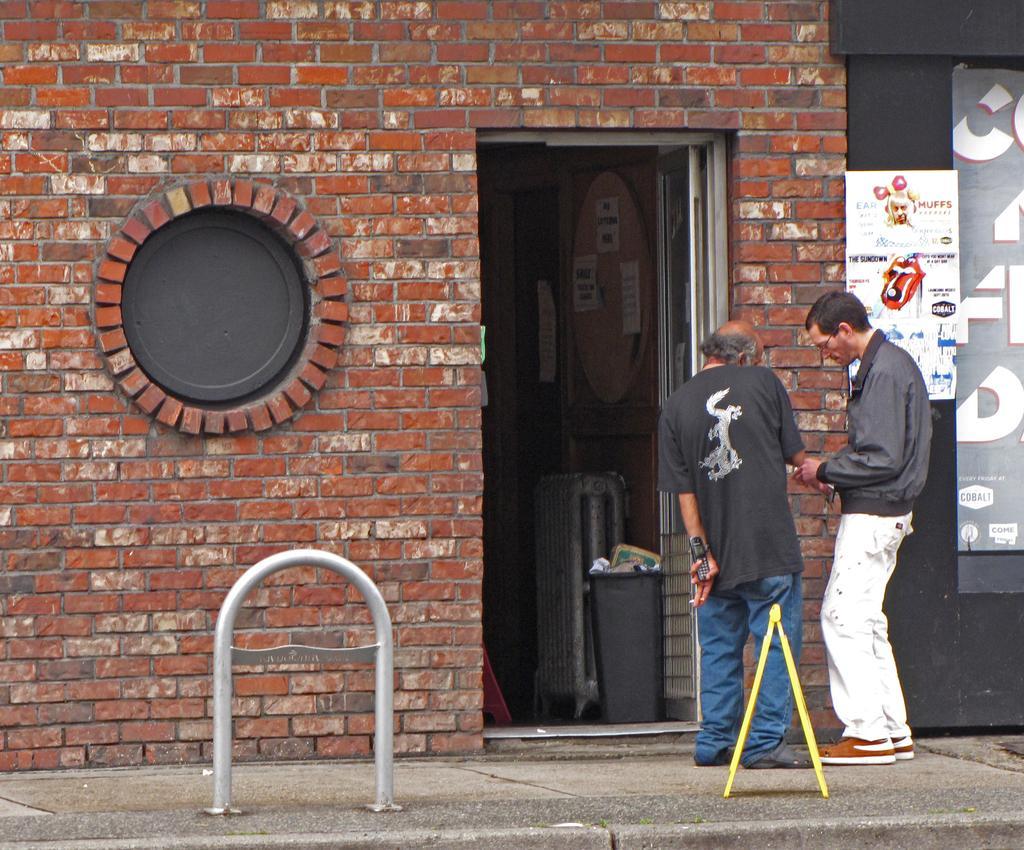Could you give a brief overview of what you see in this image? In this image I can see two men are standing and I can see one of them is holding a phone. I can also see red colour building, a yellow colour thing over here and in background I can see few boards. On these words I can see something is written. 